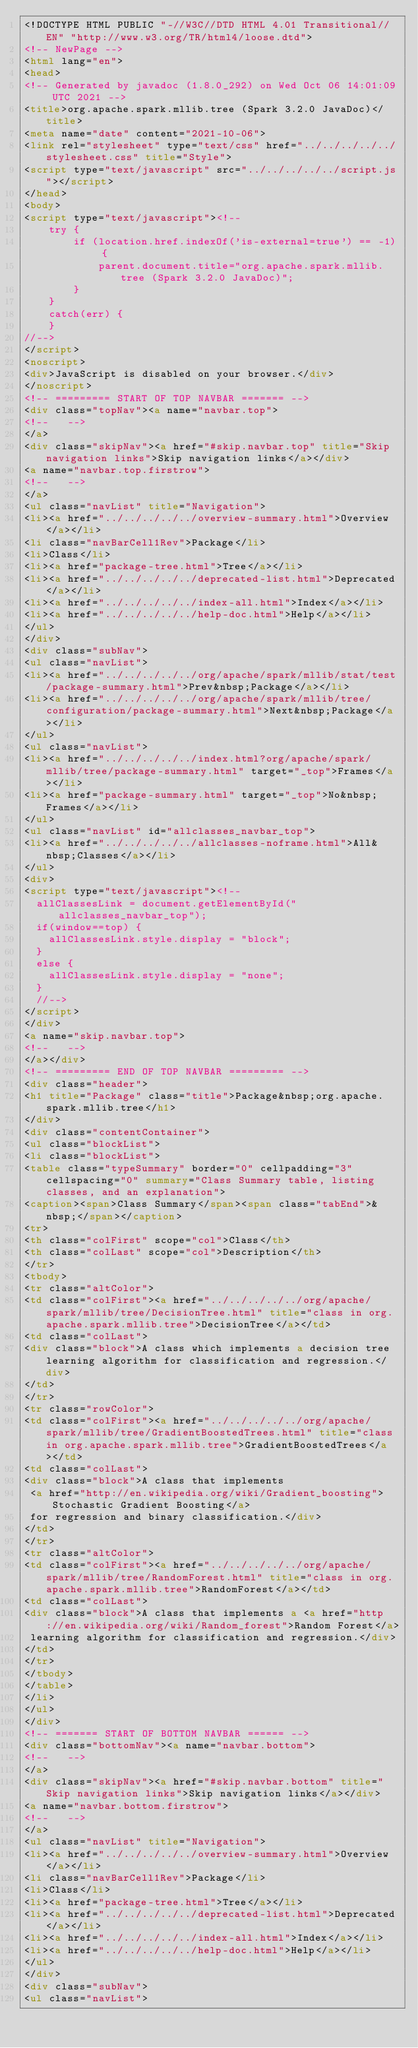<code> <loc_0><loc_0><loc_500><loc_500><_HTML_><!DOCTYPE HTML PUBLIC "-//W3C//DTD HTML 4.01 Transitional//EN" "http://www.w3.org/TR/html4/loose.dtd">
<!-- NewPage -->
<html lang="en">
<head>
<!-- Generated by javadoc (1.8.0_292) on Wed Oct 06 14:01:09 UTC 2021 -->
<title>org.apache.spark.mllib.tree (Spark 3.2.0 JavaDoc)</title>
<meta name="date" content="2021-10-06">
<link rel="stylesheet" type="text/css" href="../../../../../stylesheet.css" title="Style">
<script type="text/javascript" src="../../../../../script.js"></script>
</head>
<body>
<script type="text/javascript"><!--
    try {
        if (location.href.indexOf('is-external=true') == -1) {
            parent.document.title="org.apache.spark.mllib.tree (Spark 3.2.0 JavaDoc)";
        }
    }
    catch(err) {
    }
//-->
</script>
<noscript>
<div>JavaScript is disabled on your browser.</div>
</noscript>
<!-- ========= START OF TOP NAVBAR ======= -->
<div class="topNav"><a name="navbar.top">
<!--   -->
</a>
<div class="skipNav"><a href="#skip.navbar.top" title="Skip navigation links">Skip navigation links</a></div>
<a name="navbar.top.firstrow">
<!--   -->
</a>
<ul class="navList" title="Navigation">
<li><a href="../../../../../overview-summary.html">Overview</a></li>
<li class="navBarCell1Rev">Package</li>
<li>Class</li>
<li><a href="package-tree.html">Tree</a></li>
<li><a href="../../../../../deprecated-list.html">Deprecated</a></li>
<li><a href="../../../../../index-all.html">Index</a></li>
<li><a href="../../../../../help-doc.html">Help</a></li>
</ul>
</div>
<div class="subNav">
<ul class="navList">
<li><a href="../../../../../org/apache/spark/mllib/stat/test/package-summary.html">Prev&nbsp;Package</a></li>
<li><a href="../../../../../org/apache/spark/mllib/tree/configuration/package-summary.html">Next&nbsp;Package</a></li>
</ul>
<ul class="navList">
<li><a href="../../../../../index.html?org/apache/spark/mllib/tree/package-summary.html" target="_top">Frames</a></li>
<li><a href="package-summary.html" target="_top">No&nbsp;Frames</a></li>
</ul>
<ul class="navList" id="allclasses_navbar_top">
<li><a href="../../../../../allclasses-noframe.html">All&nbsp;Classes</a></li>
</ul>
<div>
<script type="text/javascript"><!--
  allClassesLink = document.getElementById("allclasses_navbar_top");
  if(window==top) {
    allClassesLink.style.display = "block";
  }
  else {
    allClassesLink.style.display = "none";
  }
  //-->
</script>
</div>
<a name="skip.navbar.top">
<!--   -->
</a></div>
<!-- ========= END OF TOP NAVBAR ========= -->
<div class="header">
<h1 title="Package" class="title">Package&nbsp;org.apache.spark.mllib.tree</h1>
</div>
<div class="contentContainer">
<ul class="blockList">
<li class="blockList">
<table class="typeSummary" border="0" cellpadding="3" cellspacing="0" summary="Class Summary table, listing classes, and an explanation">
<caption><span>Class Summary</span><span class="tabEnd">&nbsp;</span></caption>
<tr>
<th class="colFirst" scope="col">Class</th>
<th class="colLast" scope="col">Description</th>
</tr>
<tbody>
<tr class="altColor">
<td class="colFirst"><a href="../../../../../org/apache/spark/mllib/tree/DecisionTree.html" title="class in org.apache.spark.mllib.tree">DecisionTree</a></td>
<td class="colLast">
<div class="block">A class which implements a decision tree learning algorithm for classification and regression.</div>
</td>
</tr>
<tr class="rowColor">
<td class="colFirst"><a href="../../../../../org/apache/spark/mllib/tree/GradientBoostedTrees.html" title="class in org.apache.spark.mllib.tree">GradientBoostedTrees</a></td>
<td class="colLast">
<div class="block">A class that implements
 <a href="http://en.wikipedia.org/wiki/Gradient_boosting">Stochastic Gradient Boosting</a>
 for regression and binary classification.</div>
</td>
</tr>
<tr class="altColor">
<td class="colFirst"><a href="../../../../../org/apache/spark/mllib/tree/RandomForest.html" title="class in org.apache.spark.mllib.tree">RandomForest</a></td>
<td class="colLast">
<div class="block">A class that implements a <a href="http://en.wikipedia.org/wiki/Random_forest">Random Forest</a>
 learning algorithm for classification and regression.</div>
</td>
</tr>
</tbody>
</table>
</li>
</ul>
</div>
<!-- ======= START OF BOTTOM NAVBAR ====== -->
<div class="bottomNav"><a name="navbar.bottom">
<!--   -->
</a>
<div class="skipNav"><a href="#skip.navbar.bottom" title="Skip navigation links">Skip navigation links</a></div>
<a name="navbar.bottom.firstrow">
<!--   -->
</a>
<ul class="navList" title="Navigation">
<li><a href="../../../../../overview-summary.html">Overview</a></li>
<li class="navBarCell1Rev">Package</li>
<li>Class</li>
<li><a href="package-tree.html">Tree</a></li>
<li><a href="../../../../../deprecated-list.html">Deprecated</a></li>
<li><a href="../../../../../index-all.html">Index</a></li>
<li><a href="../../../../../help-doc.html">Help</a></li>
</ul>
</div>
<div class="subNav">
<ul class="navList"></code> 